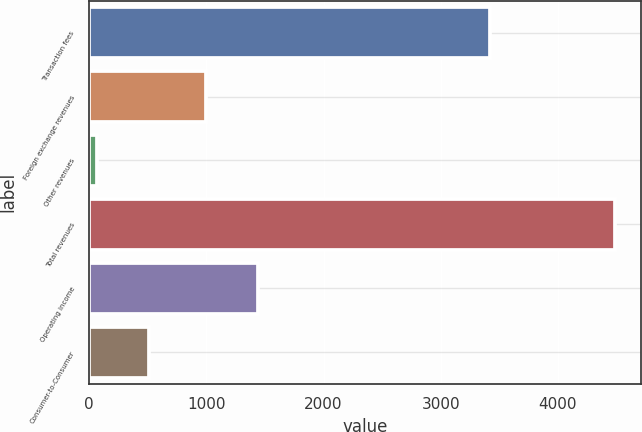Convert chart. <chart><loc_0><loc_0><loc_500><loc_500><bar_chart><fcel>Transaction fees<fcel>Foreign exchange revenues<fcel>Other revenues<fcel>Total revenues<fcel>Operating income<fcel>Consumer-to-Consumer<nl><fcel>3421.8<fcel>998.9<fcel>65.1<fcel>4485.8<fcel>1440.97<fcel>507.17<nl></chart> 